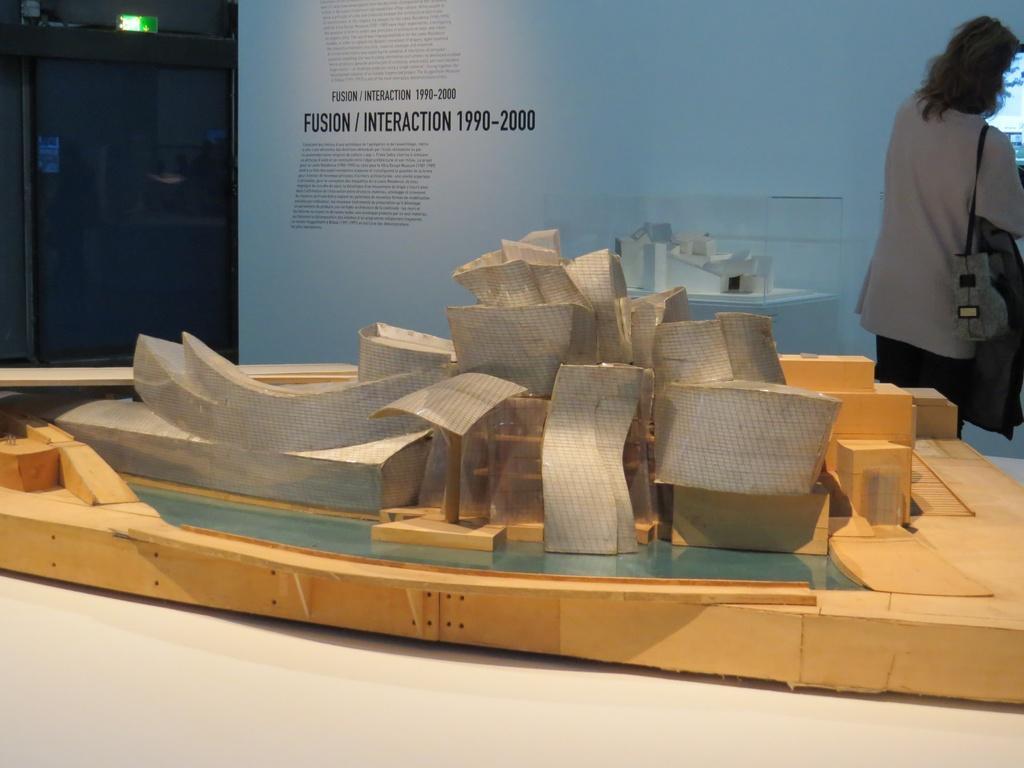Please provide a concise description of this image. In this picture we can see a woman holding a bag, side we can see a board, on which we can see some text and we can see a object looks like a boat, which is placed on the white surface. 